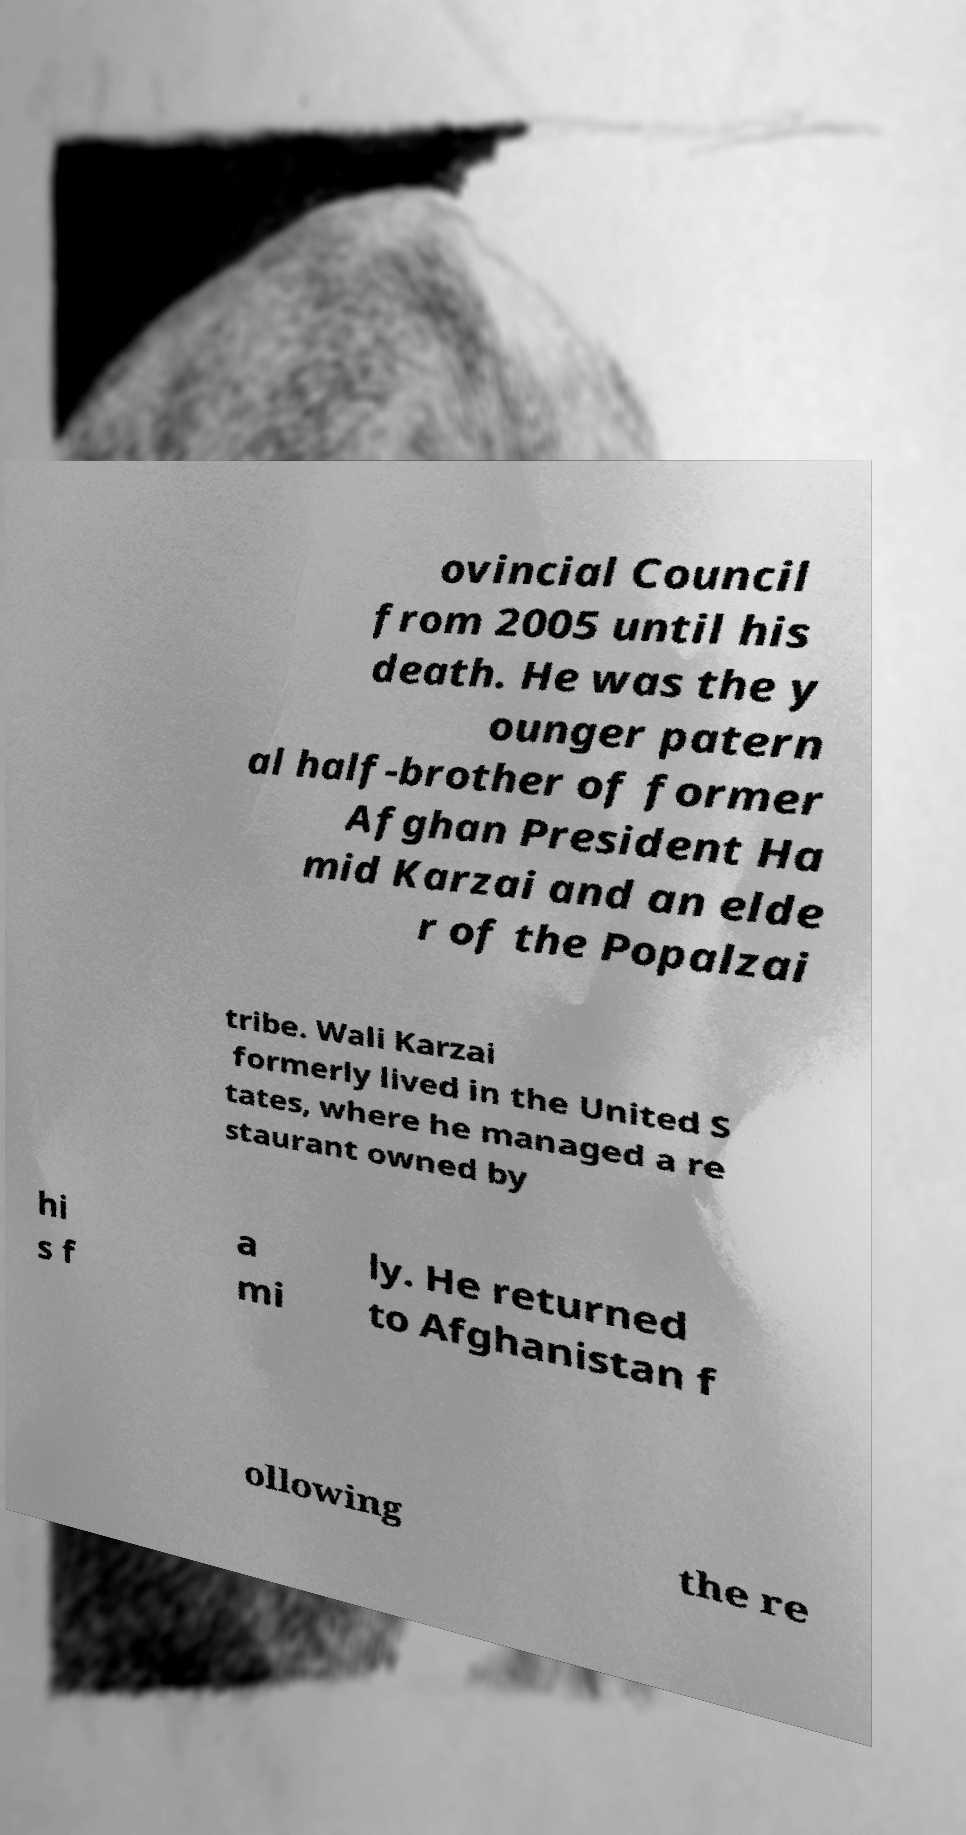Please read and relay the text visible in this image. What does it say? ovincial Council from 2005 until his death. He was the y ounger patern al half-brother of former Afghan President Ha mid Karzai and an elde r of the Popalzai tribe. Wali Karzai formerly lived in the United S tates, where he managed a re staurant owned by hi s f a mi ly. He returned to Afghanistan f ollowing the re 